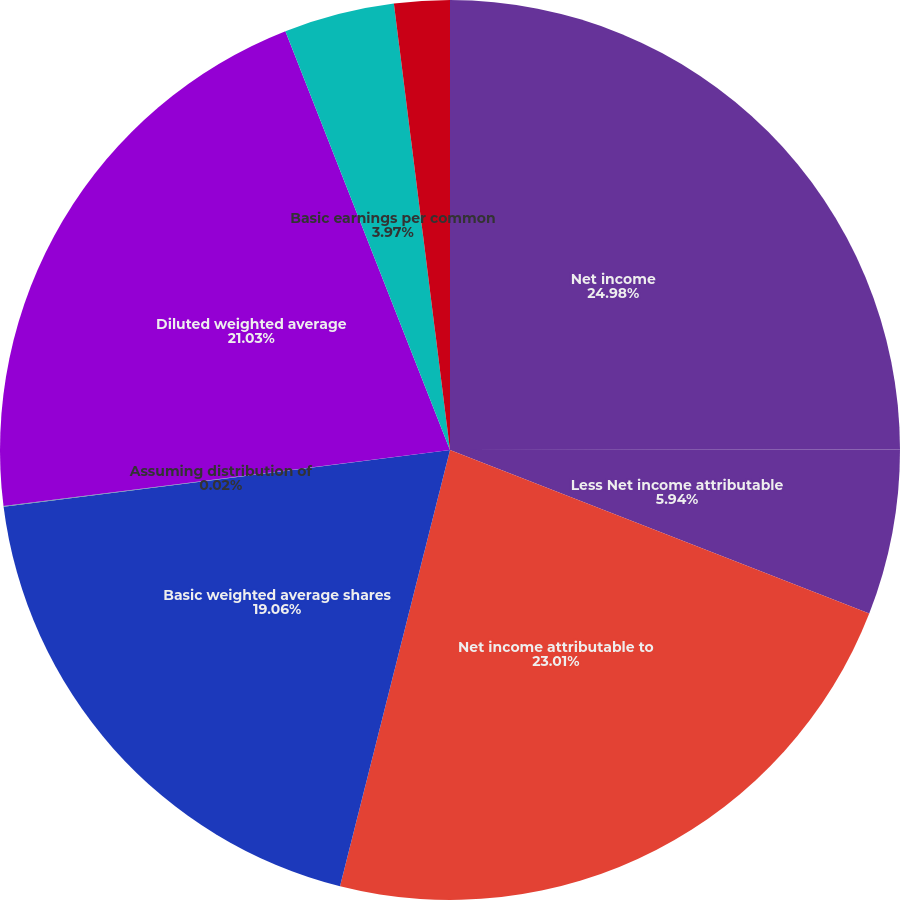Convert chart to OTSL. <chart><loc_0><loc_0><loc_500><loc_500><pie_chart><fcel>Net income<fcel>Less Net income attributable<fcel>Net income attributable to<fcel>Basic weighted average shares<fcel>Assuming distribution of<fcel>Diluted weighted average<fcel>Basic earnings per common<fcel>Diluted earnings per common<nl><fcel>24.98%<fcel>5.94%<fcel>23.01%<fcel>19.06%<fcel>0.02%<fcel>21.03%<fcel>3.97%<fcel>1.99%<nl></chart> 